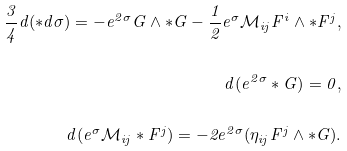Convert formula to latex. <formula><loc_0><loc_0><loc_500><loc_500>\frac { 3 } { 4 } d ( \ast d \sigma ) = - e ^ { 2 \sigma } G \wedge \ast G - \frac { 1 } { 2 } e ^ { \sigma } \mathcal { M } _ { i j } F ^ { i } \wedge \ast F ^ { j } , \\ \\ d ( e ^ { 2 \sigma } \ast G ) = 0 , \\ \\ d ( e ^ { \sigma } \mathcal { M } _ { i j } \ast F ^ { j } ) = - 2 e ^ { 2 \sigma } ( \eta _ { i j } F ^ { j } \wedge \ast G ) .</formula> 